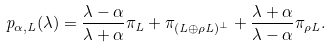<formula> <loc_0><loc_0><loc_500><loc_500>p _ { \alpha , L } ( \lambda ) = \frac { \lambda - \alpha } { \lambda + \alpha } \pi _ { L } + \pi _ { ( L \oplus \rho L ) ^ { \perp } } + \frac { \lambda + \alpha } { \lambda - \alpha } \pi _ { \rho L } .</formula> 